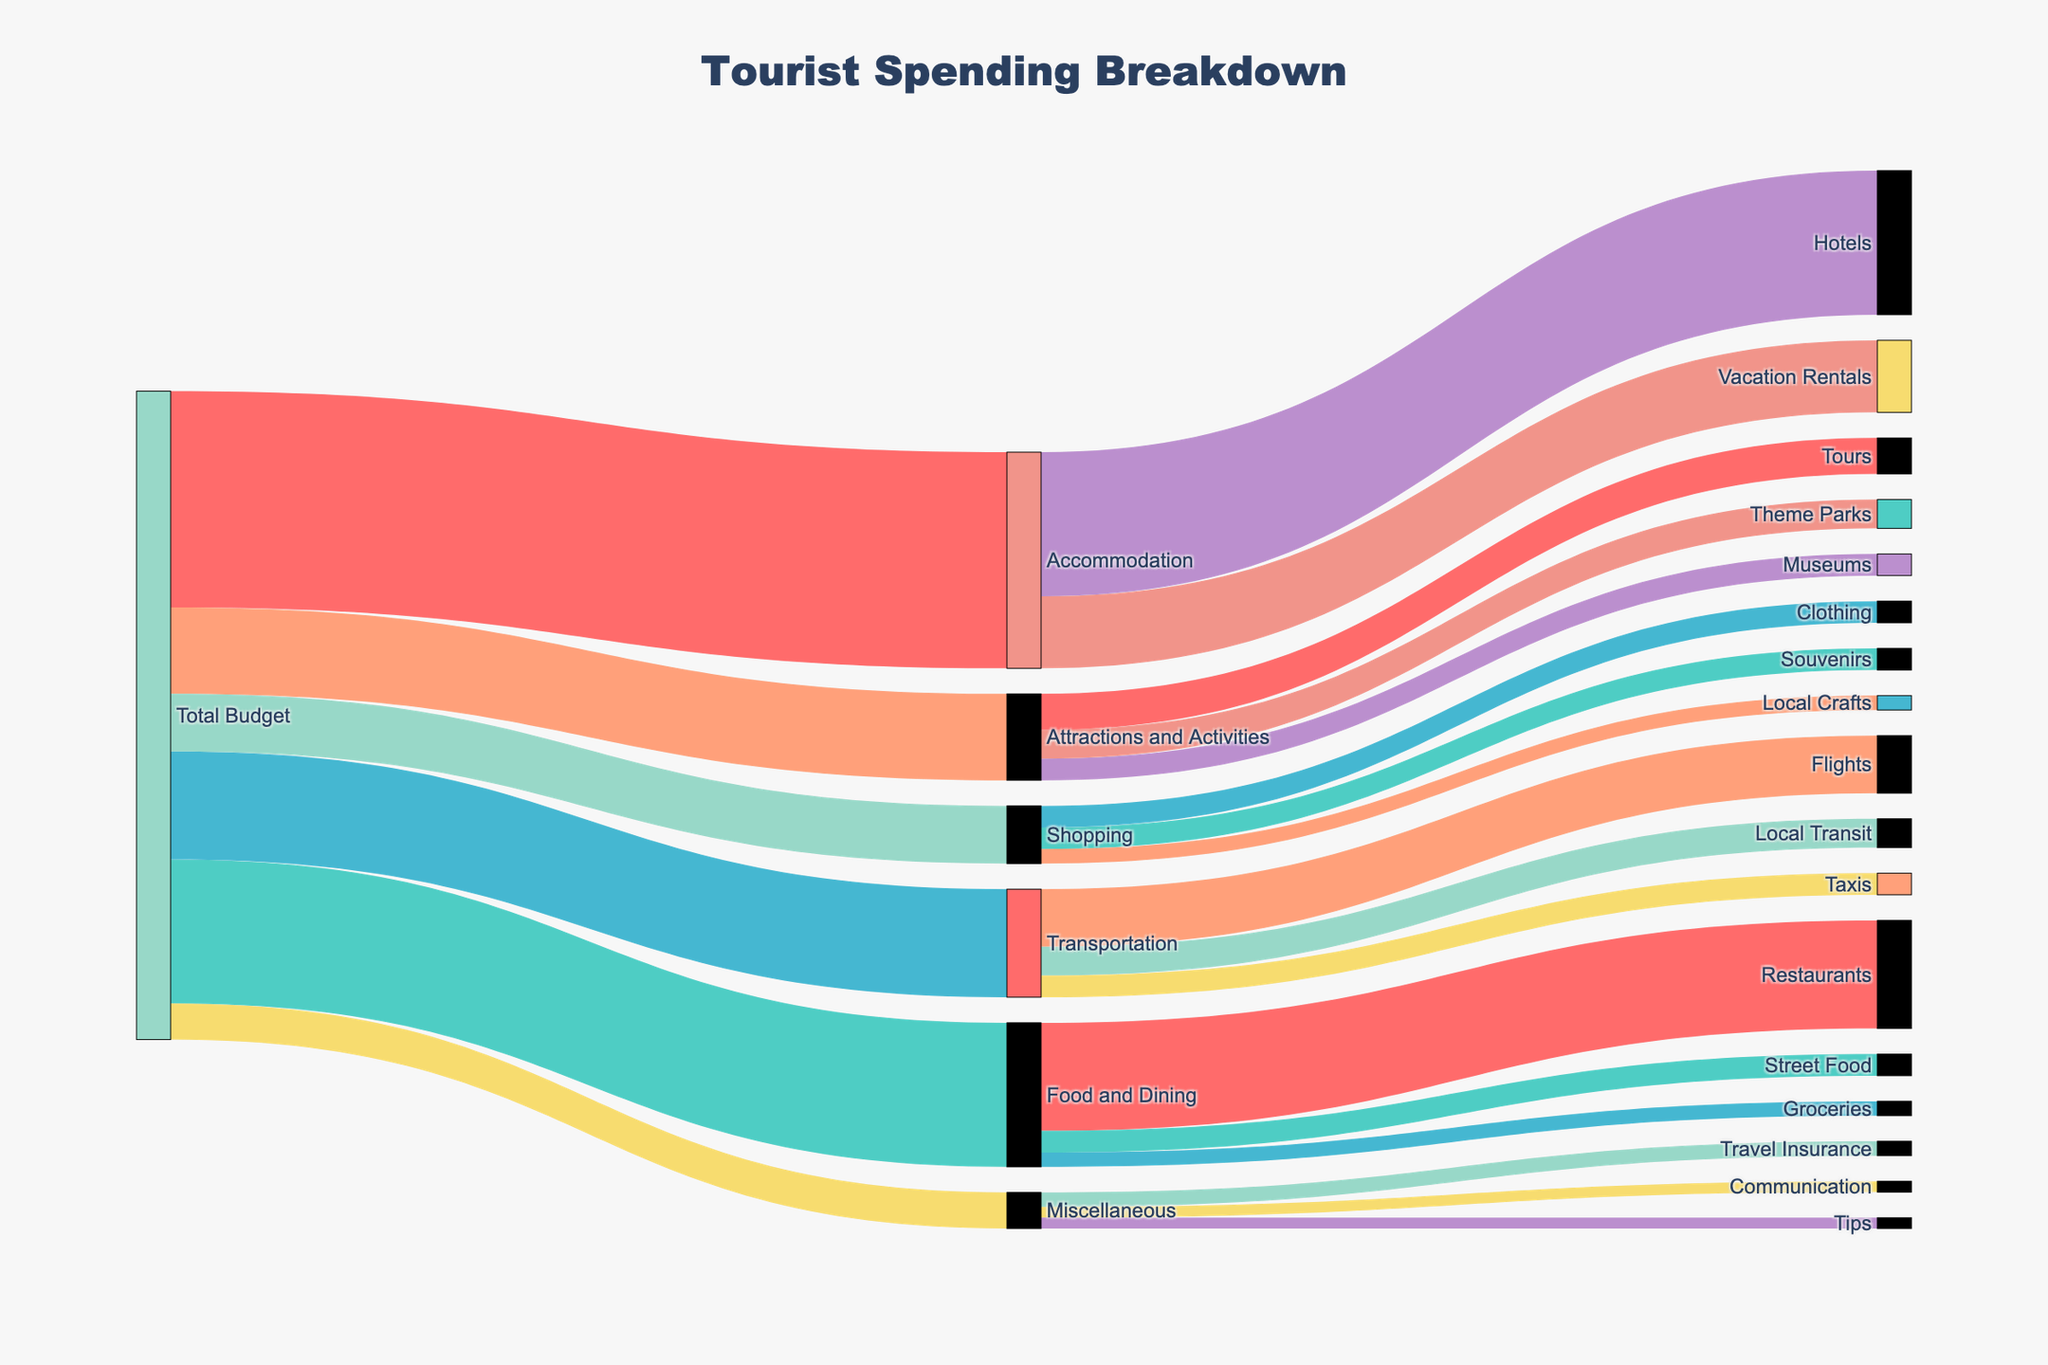what is the total budget allocated for Tourist spending? To find the total budget, look for the label at the start of the Sankey diagram, which is 'Total Budget'. The value associated with it is provided as 9000, the sum of the values flowing from 'Total Budget' to different categories.
Answer: 9000 How much is being spent on Food and Dining? Look at the Sankey diagram, find the flow from 'Total Budget' to 'Food and Dining', and check the value associated with it, which is 2000.
Answer: 2000 What proportion of the total budget is spent on Accommodation? The total budget is 9000, and the amount spent on Accommodation is 3000. To find the proportion, divide 3000 by 9000 and multiply by 100 to convert it to percentage.
Answer: 33.33% Which sub-category within Food and Dining has the highest expenditure? Look at the flows from 'Food and Dining' to its sub-categories: Restaurants, Street Food, and Groceries. The value associated with Restaurants (1500) is the highest among them.
Answer: Restaurants How much more is spent on Hotels compared to Vacation Rentals? Find the amount spent on Hotels (2000) and Vacation Rentals (1000) from the Accommodation category. Subtract the smaller value from the larger one: 2000 - 1000.
Answer: 1000 Are there more funds allocated to Meals at Restaurants or Souvenirs while shopping? Check the values associated with Restaurants (1500) and Souvenirs (300). Compare the two; Restaurants have a higher allocation.
Answer: Restaurants What is the least funded sub-category in the chart? Compare the values for all sub-categories: Groceries (200), Local Crafts (200), Tips (150), and Communications (150). The lowest equal values are Tips and Communications at 150 each.
Answer: Tips and Communication How does spending on Attractions and Activities compare to Transportation? Find the values for Attractions and Activities (1200) and Transportation (1500). Transportation has a higher value.
Answer: Transportation What percentage of the Food and Dining budget goes to Street Food? The budget for Food and Dining is 2000, and the amount for Street Food is 300. To find the percentage, divide 300 by 2000 and multiply by 100.
Answer: 15% What is the total amount allocated to non-essential categories like Shopping and Miscellaneous? Add the values for Shopping (800) and Miscellaneous (500). Sum is 800 + 500.
Answer: 1300 